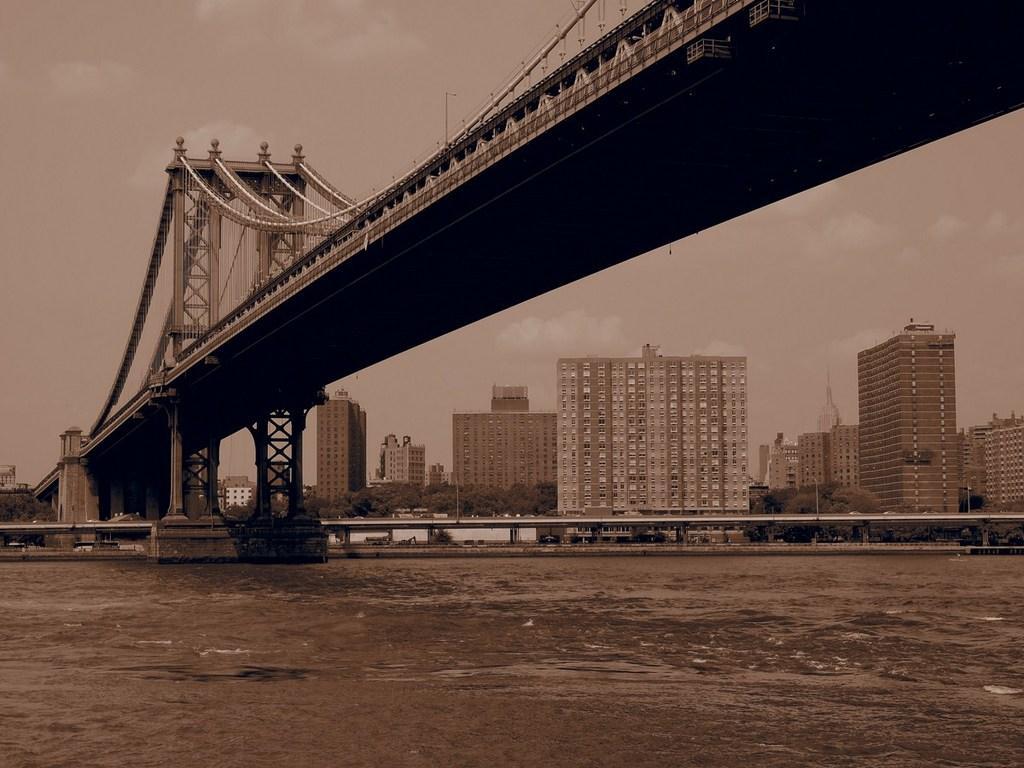Could you give a brief overview of what you see in this image? In this image there is a lake at bottom of this image and there is a bridge at top of this image. There is one flyover at bottom of this image and there are some trees in the background and there are some building in middle of this image and there is a sky at top of this image. 